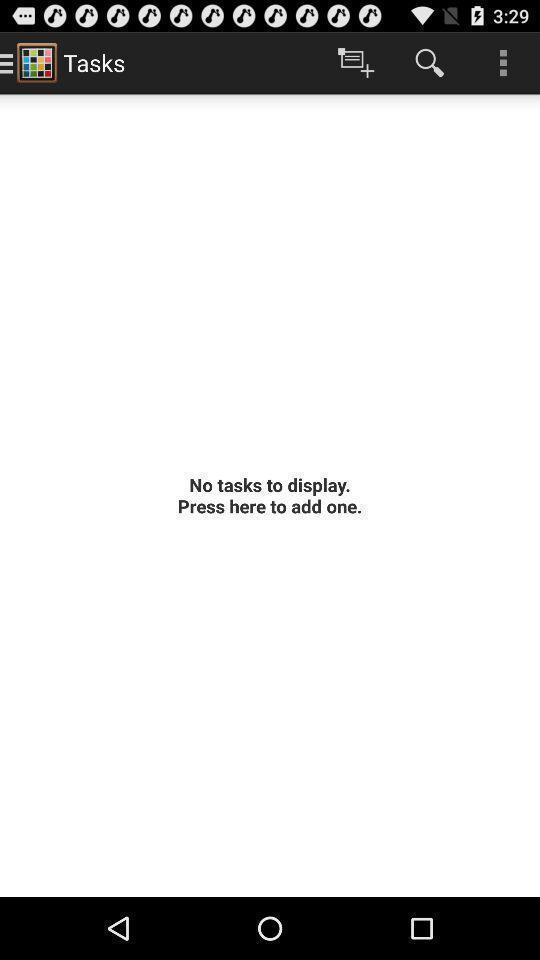What can you discern from this picture? Search icon is being displayed in the app. 